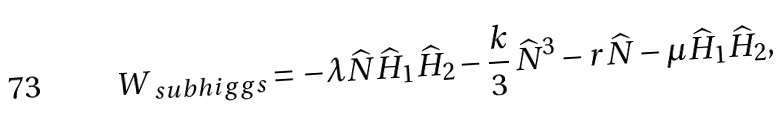Convert formula to latex. <formula><loc_0><loc_0><loc_500><loc_500>W _ { \ s u b h i g g s } = - \lambda \widehat { N } \widehat { H } _ { 1 } \widehat { H } _ { 2 } - \frac { k } { 3 } \, { \widehat { N } } ^ { 3 } - r \widehat { N } - \mu \widehat { H } _ { 1 } \widehat { H } _ { 2 } ,</formula> 